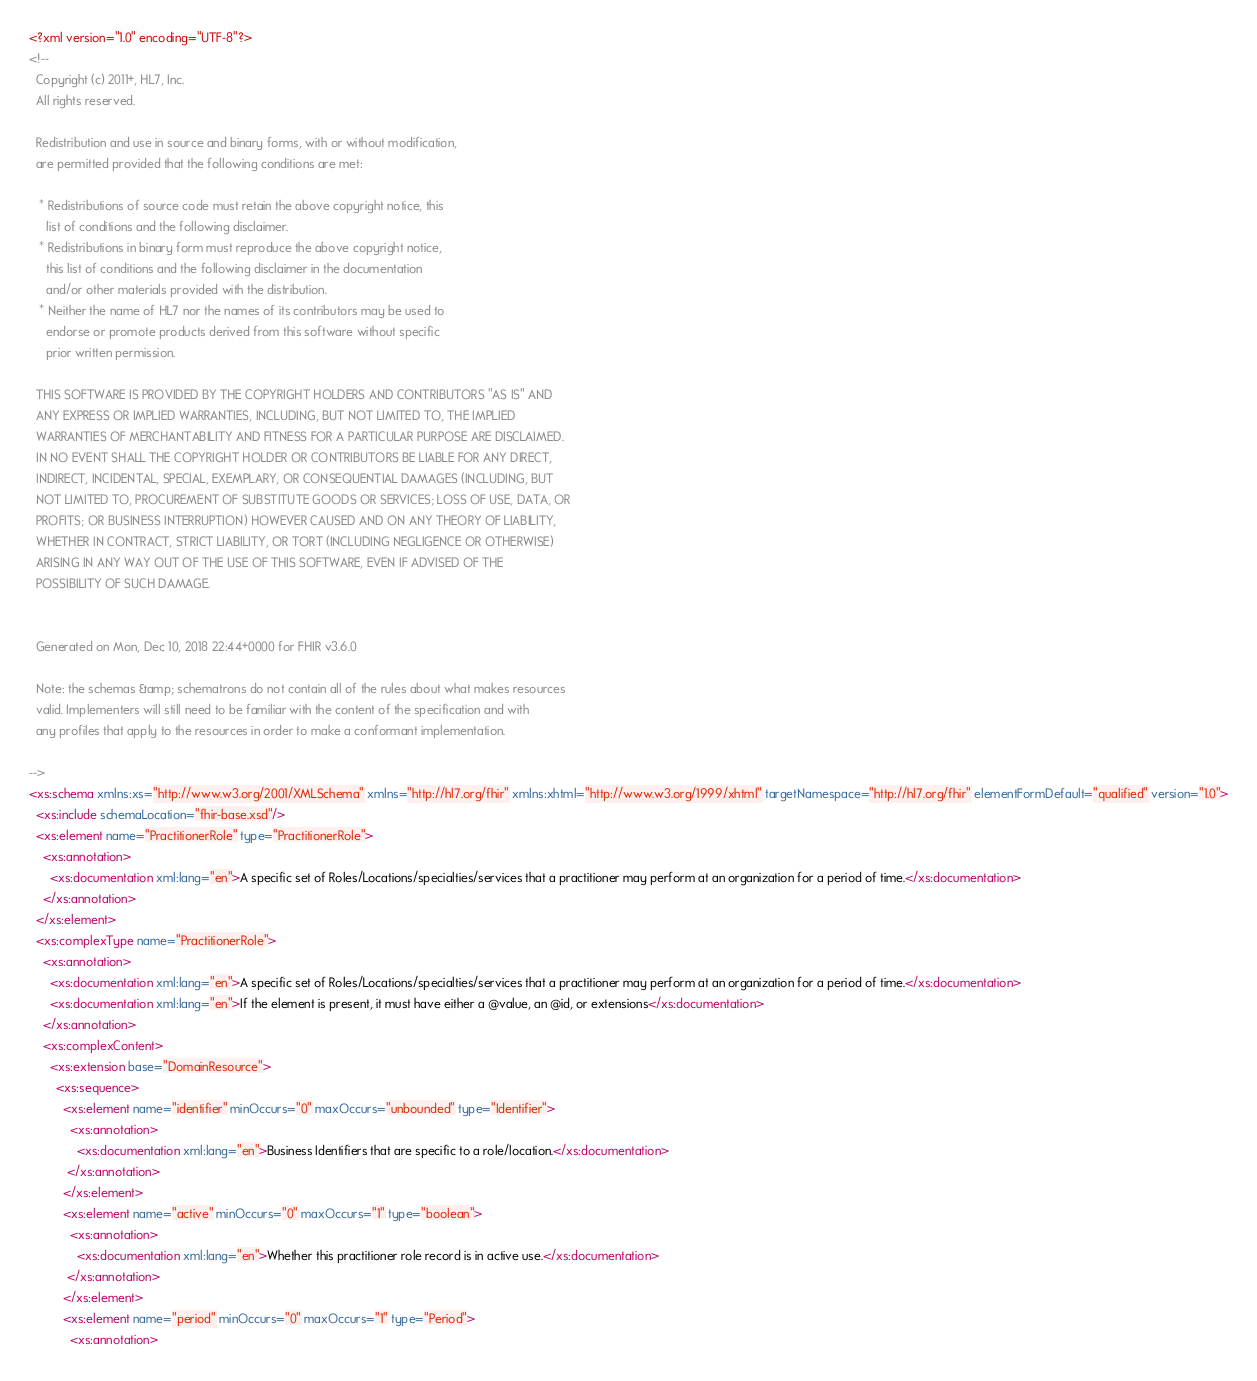<code> <loc_0><loc_0><loc_500><loc_500><_XML_><?xml version="1.0" encoding="UTF-8"?>
<!-- 
  Copyright (c) 2011+, HL7, Inc.
  All rights reserved.
  
  Redistribution and use in source and binary forms, with or without modification, 
  are permitted provided that the following conditions are met:
  
   * Redistributions of source code must retain the above copyright notice, this 
     list of conditions and the following disclaimer.
   * Redistributions in binary form must reproduce the above copyright notice, 
     this list of conditions and the following disclaimer in the documentation 
     and/or other materials provided with the distribution.
   * Neither the name of HL7 nor the names of its contributors may be used to 
     endorse or promote products derived from this software without specific 
     prior written permission.
  
  THIS SOFTWARE IS PROVIDED BY THE COPYRIGHT HOLDERS AND CONTRIBUTORS "AS IS" AND 
  ANY EXPRESS OR IMPLIED WARRANTIES, INCLUDING, BUT NOT LIMITED TO, THE IMPLIED 
  WARRANTIES OF MERCHANTABILITY AND FITNESS FOR A PARTICULAR PURPOSE ARE DISCLAIMED. 
  IN NO EVENT SHALL THE COPYRIGHT HOLDER OR CONTRIBUTORS BE LIABLE FOR ANY DIRECT, 
  INDIRECT, INCIDENTAL, SPECIAL, EXEMPLARY, OR CONSEQUENTIAL DAMAGES (INCLUDING, BUT 
  NOT LIMITED TO, PROCUREMENT OF SUBSTITUTE GOODS OR SERVICES; LOSS OF USE, DATA, OR 
  PROFITS; OR BUSINESS INTERRUPTION) HOWEVER CAUSED AND ON ANY THEORY OF LIABILITY, 
  WHETHER IN CONTRACT, STRICT LIABILITY, OR TORT (INCLUDING NEGLIGENCE OR OTHERWISE) 
  ARISING IN ANY WAY OUT OF THE USE OF THIS SOFTWARE, EVEN IF ADVISED OF THE 
  POSSIBILITY OF SUCH DAMAGE.
  

  Generated on Mon, Dec 10, 2018 22:44+0000 for FHIR v3.6.0 

  Note: the schemas &amp; schematrons do not contain all of the rules about what makes resources
  valid. Implementers will still need to be familiar with the content of the specification and with
  any profiles that apply to the resources in order to make a conformant implementation.

-->
<xs:schema xmlns:xs="http://www.w3.org/2001/XMLSchema" xmlns="http://hl7.org/fhir" xmlns:xhtml="http://www.w3.org/1999/xhtml" targetNamespace="http://hl7.org/fhir" elementFormDefault="qualified" version="1.0">
  <xs:include schemaLocation="fhir-base.xsd"/>
  <xs:element name="PractitionerRole" type="PractitionerRole">
    <xs:annotation>
      <xs:documentation xml:lang="en">A specific set of Roles/Locations/specialties/services that a practitioner may perform at an organization for a period of time.</xs:documentation>
    </xs:annotation>
  </xs:element>
  <xs:complexType name="PractitionerRole">
    <xs:annotation>
      <xs:documentation xml:lang="en">A specific set of Roles/Locations/specialties/services that a practitioner may perform at an organization for a period of time.</xs:documentation>
      <xs:documentation xml:lang="en">If the element is present, it must have either a @value, an @id, or extensions</xs:documentation>
    </xs:annotation>
    <xs:complexContent>
      <xs:extension base="DomainResource">
        <xs:sequence>
          <xs:element name="identifier" minOccurs="0" maxOccurs="unbounded" type="Identifier">
            <xs:annotation>
              <xs:documentation xml:lang="en">Business Identifiers that are specific to a role/location.</xs:documentation>
           </xs:annotation>
          </xs:element>
          <xs:element name="active" minOccurs="0" maxOccurs="1" type="boolean">
            <xs:annotation>
              <xs:documentation xml:lang="en">Whether this practitioner role record is in active use.</xs:documentation>
           </xs:annotation>
          </xs:element>
          <xs:element name="period" minOccurs="0" maxOccurs="1" type="Period">
            <xs:annotation></code> 